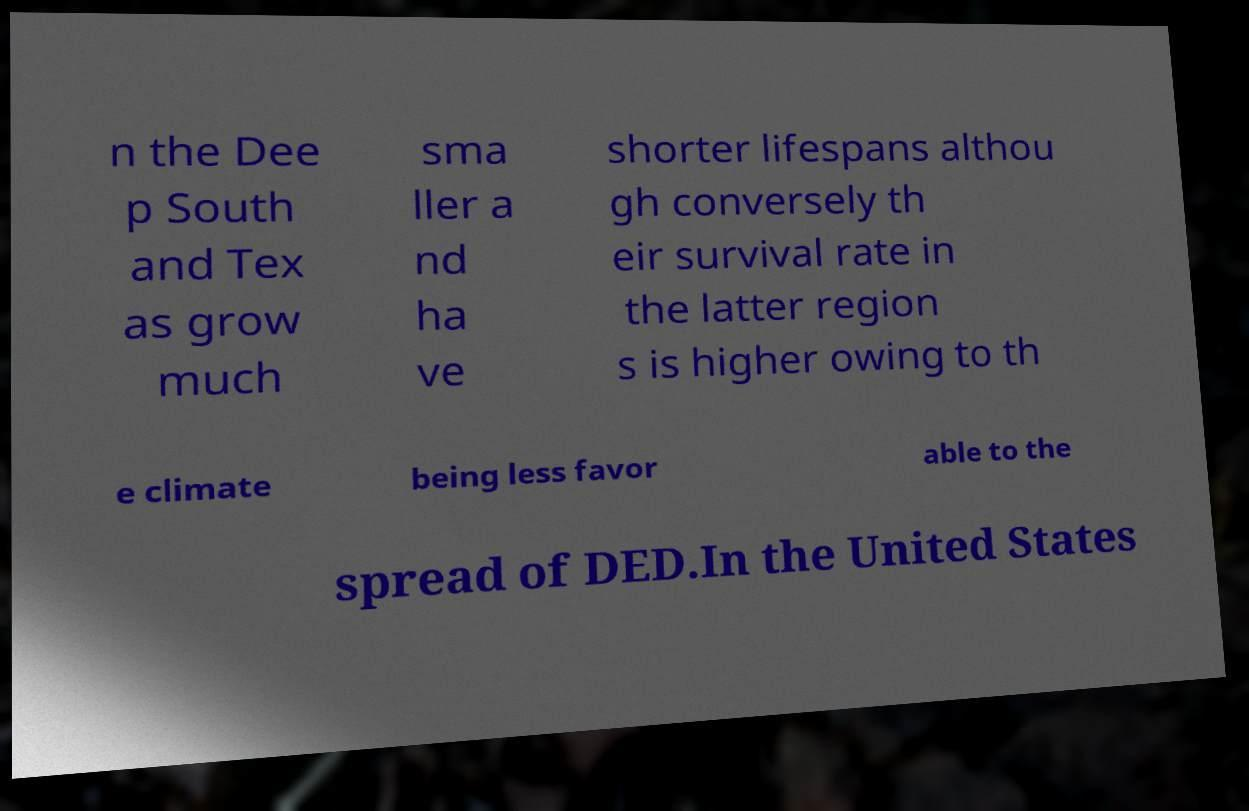Can you read and provide the text displayed in the image?This photo seems to have some interesting text. Can you extract and type it out for me? n the Dee p South and Tex as grow much sma ller a nd ha ve shorter lifespans althou gh conversely th eir survival rate in the latter region s is higher owing to th e climate being less favor able to the spread of DED.In the United States 